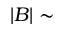<formula> <loc_0><loc_0><loc_500><loc_500>| B | \sim</formula> 